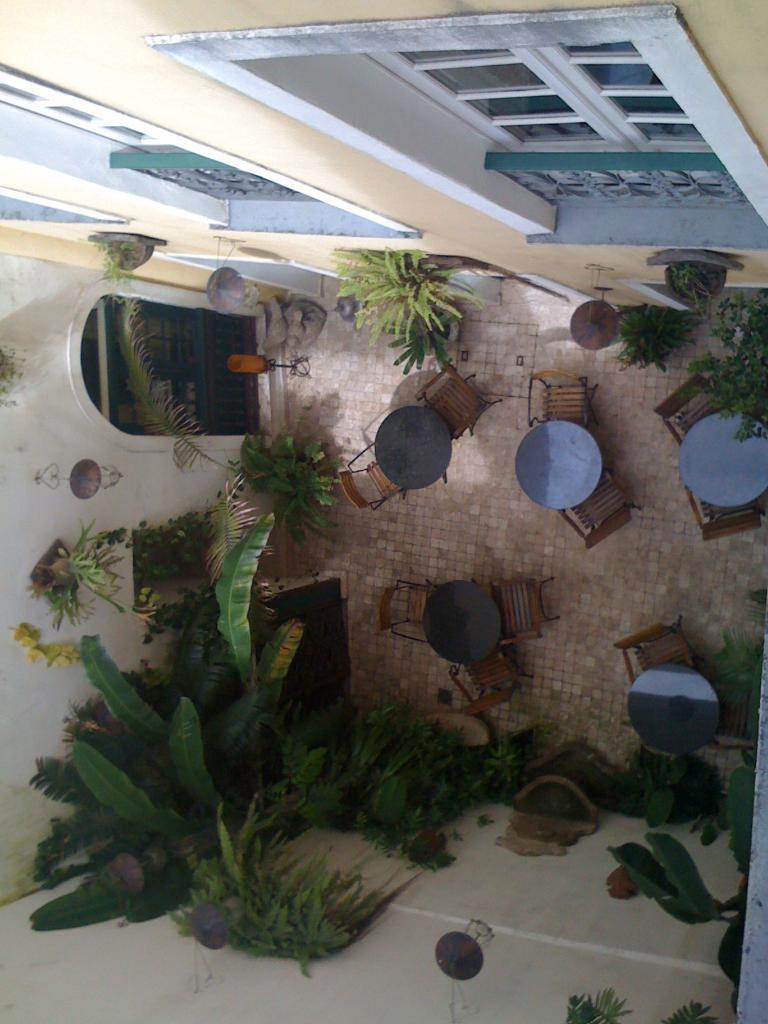What type of furniture is present in the room? There is a table in the room. Are there any seating options around the table? Yes, there are chairs around the table. What decorative element can be seen on the wall? There are plants on the wall. What allows natural light to enter the room? There are windows in the room. What type of stocking is being used to mark the territory in the room? There is no mention of stockings or territory marking in the image. The image only shows a table, chairs, plants on the wall, and windows. 